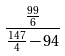Convert formula to latex. <formula><loc_0><loc_0><loc_500><loc_500>\frac { \frac { 9 9 } { 6 } } { \frac { 1 4 7 } { 4 } - 9 4 }</formula> 